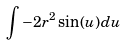Convert formula to latex. <formula><loc_0><loc_0><loc_500><loc_500>\int - 2 r ^ { 2 } \sin ( u ) d u</formula> 